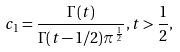Convert formula to latex. <formula><loc_0><loc_0><loc_500><loc_500>c _ { 1 } = \frac { \Gamma \left ( t \right ) } { \Gamma ( t - 1 / 2 ) \pi ^ { \frac { 1 } { 2 } } } , t > \frac { 1 } { 2 } ,</formula> 